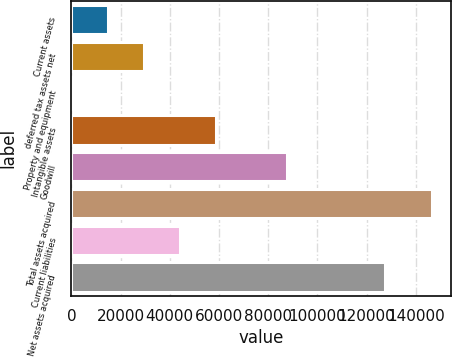Convert chart. <chart><loc_0><loc_0><loc_500><loc_500><bar_chart><fcel>Current assets<fcel>deferred tax assets net<fcel>Property and equipment<fcel>Intangible assets<fcel>Goodwill<fcel>Total assets acquired<fcel>Current liabilities<fcel>Net assets acquired<nl><fcel>15001<fcel>29642<fcel>360<fcel>58924<fcel>87482<fcel>146770<fcel>44283<fcel>127450<nl></chart> 